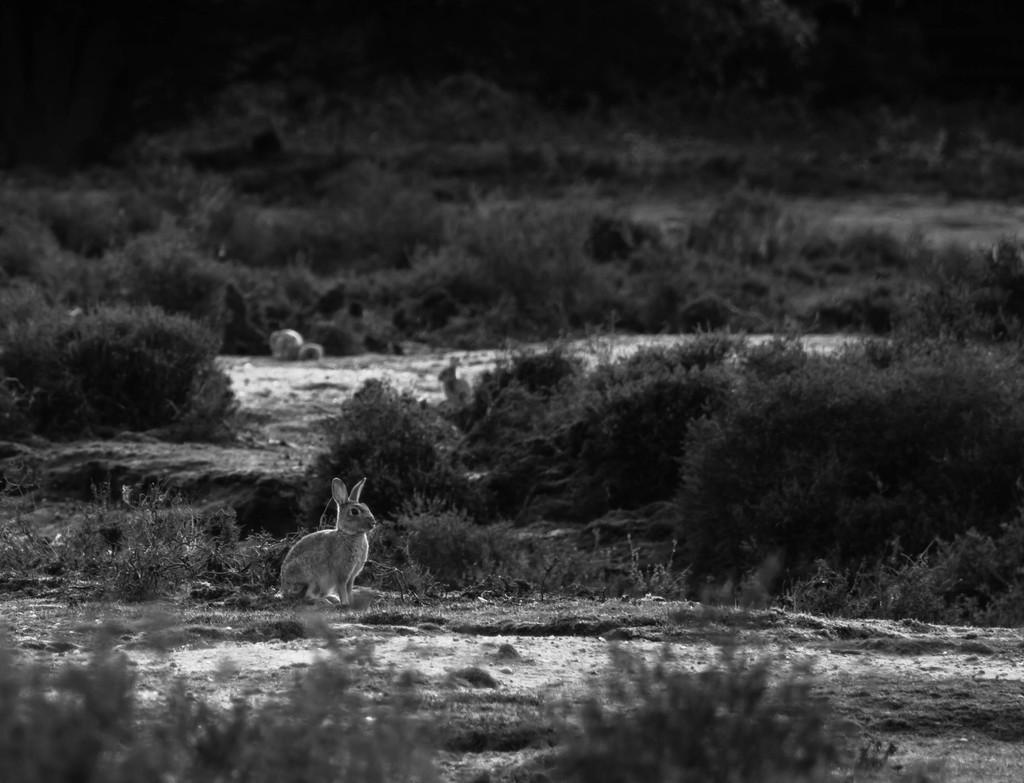How would you summarize this image in a sentence or two? This is the picture of a rabbit which is on the floor and around there are some plants, trees and grass on the floor. 